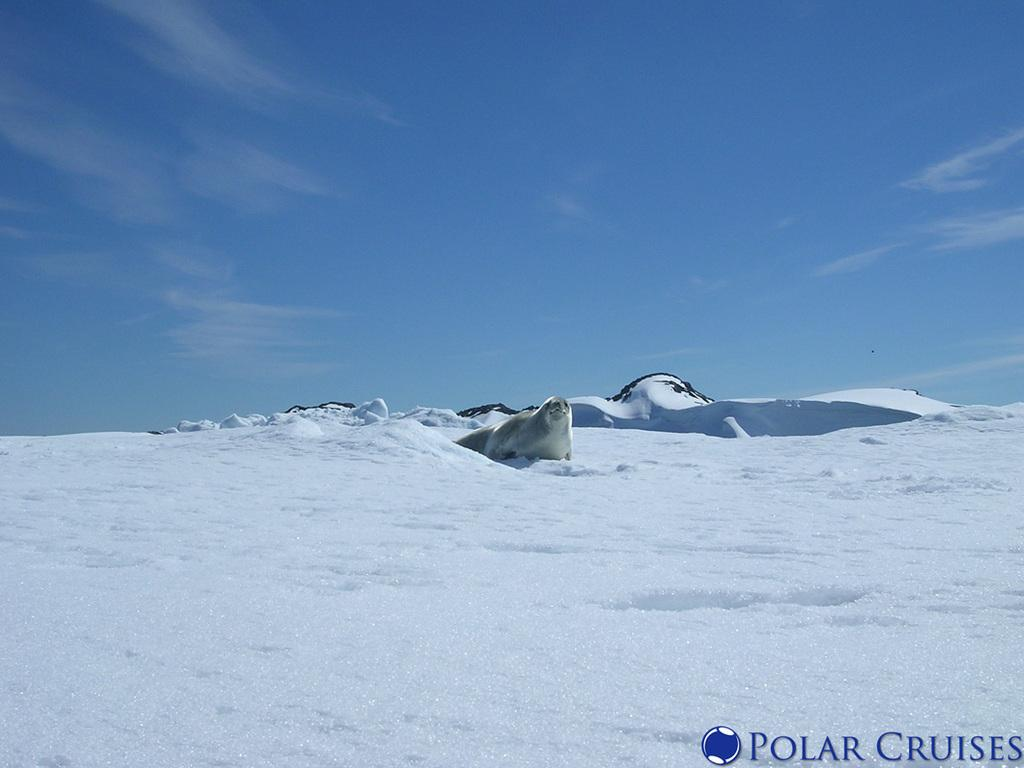What type of animal can be seen in the picture? There is a polar animal in the picture. What is the environment like in the picture? There is snow visible in the picture, indicating a cold climate. What can be seen in the sky in the picture? There are clouds in the sky in the picture. What type of badge is the polar animal wearing in the picture? There is no badge visible on the polar animal in the picture. What unit is responsible for taking care of the polar animal in the picture? The picture does not indicate any specific unit responsible for the polar animal, as it is not in a zoo or any other managed environment. 